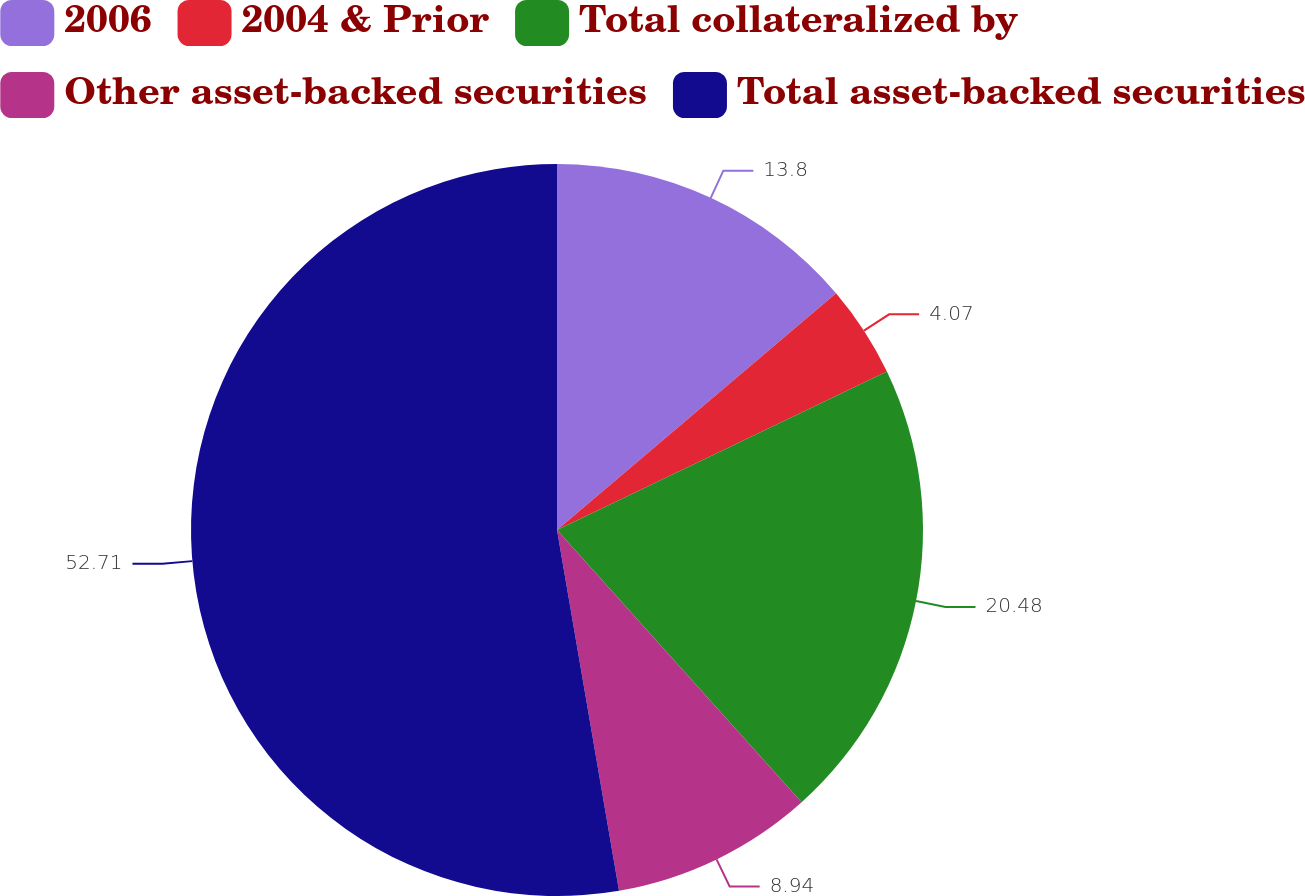<chart> <loc_0><loc_0><loc_500><loc_500><pie_chart><fcel>2006<fcel>2004 & Prior<fcel>Total collateralized by<fcel>Other asset-backed securities<fcel>Total asset-backed securities<nl><fcel>13.8%<fcel>4.07%<fcel>20.48%<fcel>8.94%<fcel>52.71%<nl></chart> 